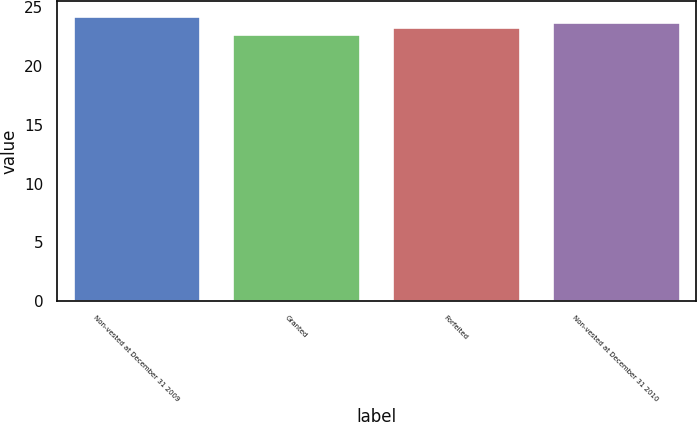<chart> <loc_0><loc_0><loc_500><loc_500><bar_chart><fcel>Non-vested at December 31 2009<fcel>Granted<fcel>Forfeited<fcel>Non-vested at December 31 2010<nl><fcel>24.27<fcel>22.7<fcel>23.29<fcel>23.71<nl></chart> 